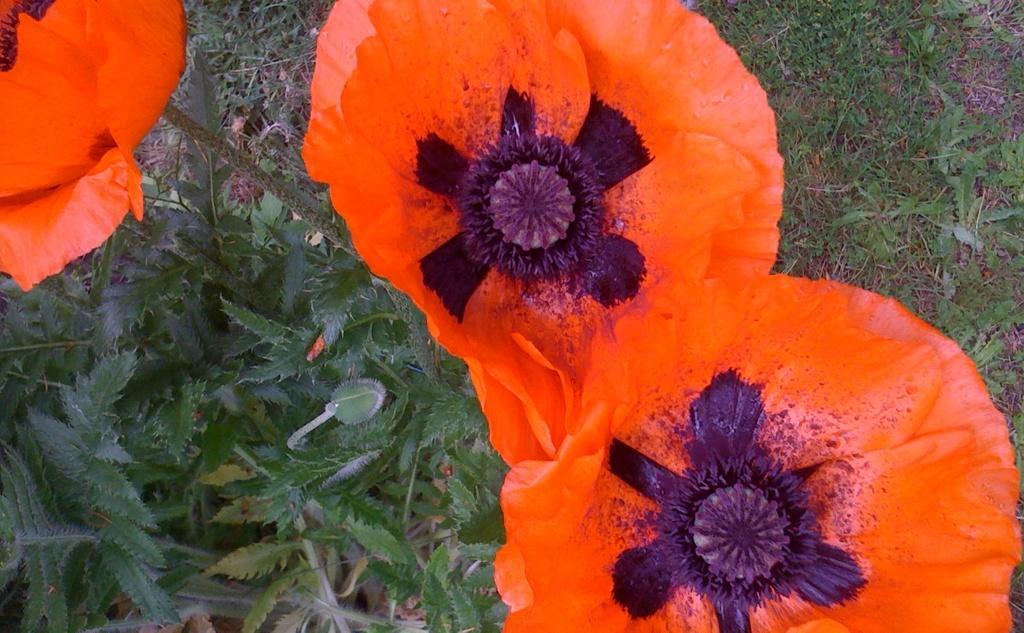In one or two sentences, can you explain what this image depicts? In this image I can see few orange colour flowers and number of green colour leaves in the front. On the right side of this image I can see grass. 